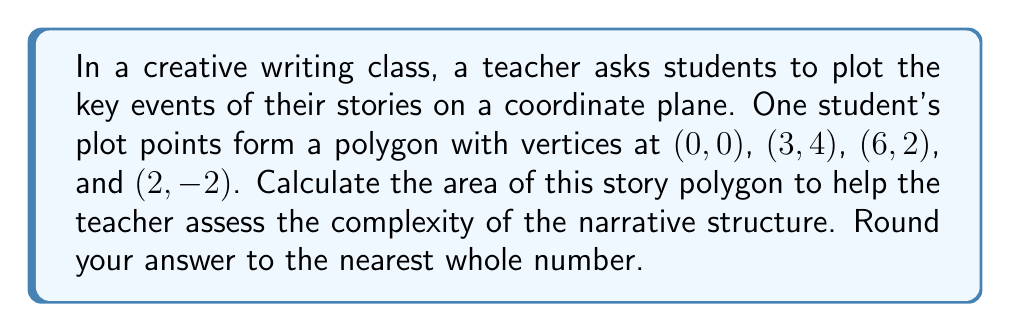Could you help me with this problem? Let's approach this step-by-step:

1) The given points form a quadrilateral. We can calculate its area using the Shoelace formula (also known as the surveyor's formula).

2) The Shoelace formula for a polygon with vertices $(x_1, y_1), (x_2, y_2), ..., (x_n, y_n)$ is:

   $$A = \frac{1}{2}|(x_1y_2 + x_2y_3 + ... + x_ny_1) - (y_1x_2 + y_2x_3 + ... + y_nx_1)|$$

3) Let's organize our points:
   $(x_1, y_1) = (0, 0)$
   $(x_2, y_2) = (3, 4)$
   $(x_3, y_3) = (6, 2)$
   $(x_4, y_4) = (2, -2)$

4) Now, let's apply the formula:

   $$A = \frac{1}{2}|(0 \cdot 4 + 3 \cdot 2 + 6 \cdot (-2) + 2 \cdot 0) - (0 \cdot 3 + 4 \cdot 6 + 2 \cdot 2 + (-2) \cdot 0)|$$

5) Simplify:
   $$A = \frac{1}{2}|(0 + 6 - 12 + 0) - (0 + 24 + 4 + 0)|$$
   $$A = \frac{1}{2}|(-6) - (28)|$$
   $$A = \frac{1}{2}|-34|$$
   $$A = \frac{1}{2}(34)$$
   $$A = 17$$

6) The question asks to round to the nearest whole number, but 17 is already a whole number.

Therefore, the area of the story polygon is 17 square units.
Answer: 17 square units 